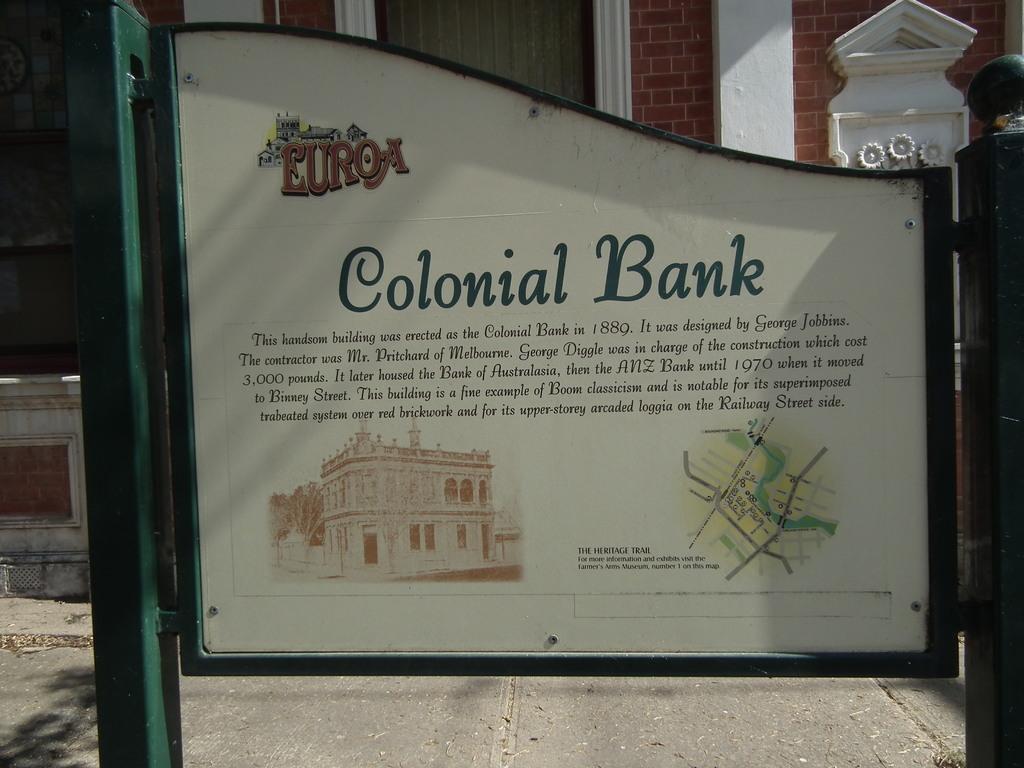Where is this city?
Ensure brevity in your answer.  Euroa. Which bank is this?
Provide a succinct answer. Colonial bank. 